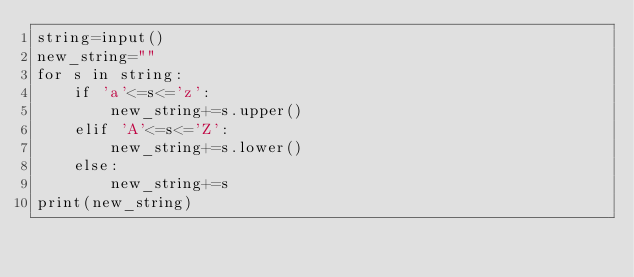<code> <loc_0><loc_0><loc_500><loc_500><_Python_>string=input()
new_string=""
for s in string:
    if 'a'<=s<='z':
        new_string+=s.upper()
    elif 'A'<=s<='Z':
        new_string+=s.lower()
    else:
        new_string+=s
print(new_string)

</code> 